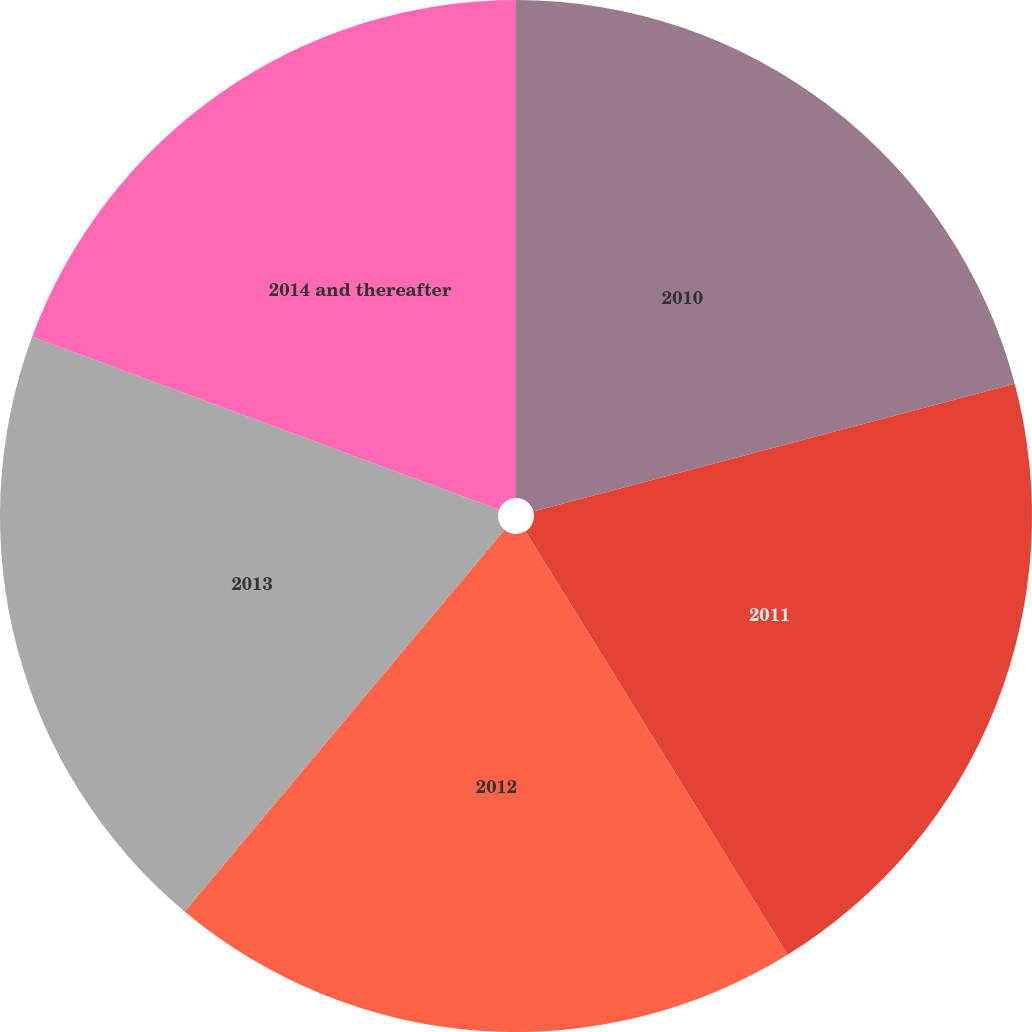Convert chart. <chart><loc_0><loc_0><loc_500><loc_500><pie_chart><fcel>2010<fcel>2011<fcel>2012<fcel>2013<fcel>2014 and thereafter<nl><fcel>20.87%<fcel>20.3%<fcel>19.92%<fcel>19.54%<fcel>19.35%<nl></chart> 